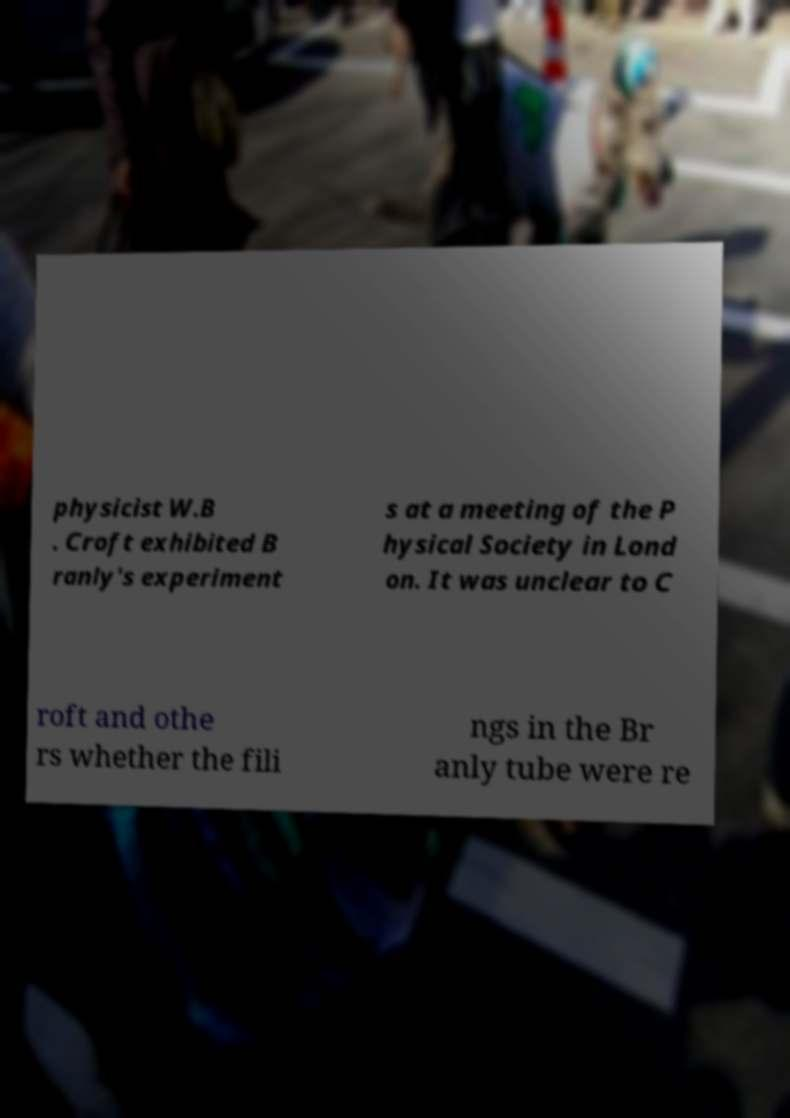There's text embedded in this image that I need extracted. Can you transcribe it verbatim? physicist W.B . Croft exhibited B ranly's experiment s at a meeting of the P hysical Society in Lond on. It was unclear to C roft and othe rs whether the fili ngs in the Br anly tube were re 